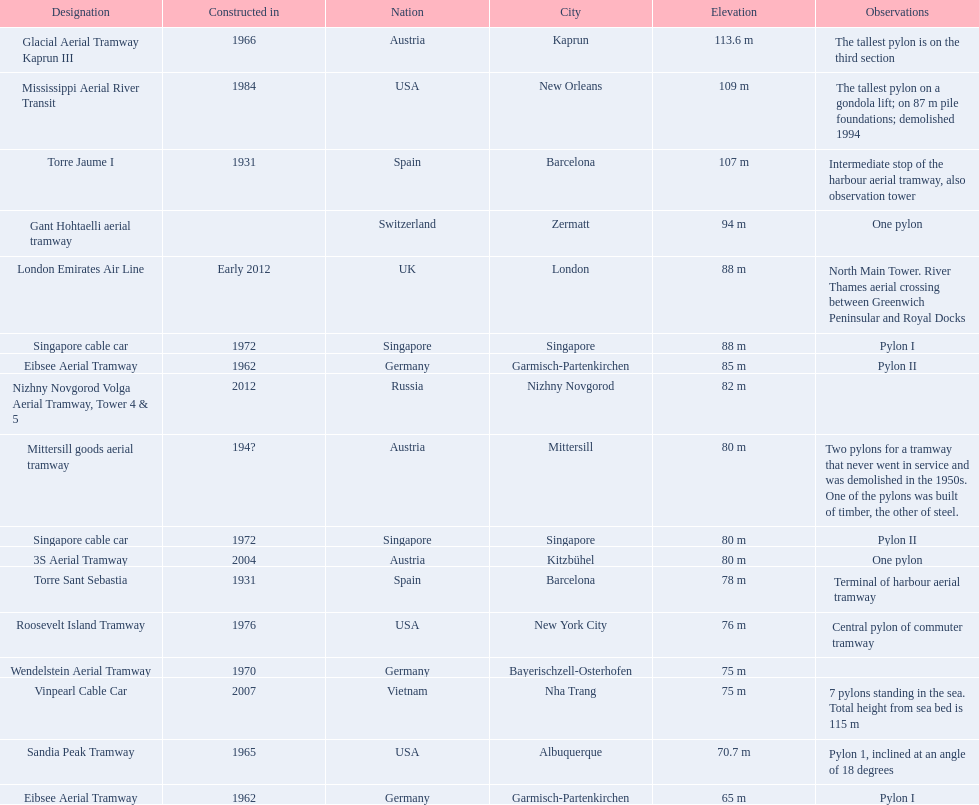Which lift has the second highest height? Mississippi Aerial River Transit. What is the value of the height? 109 m. 